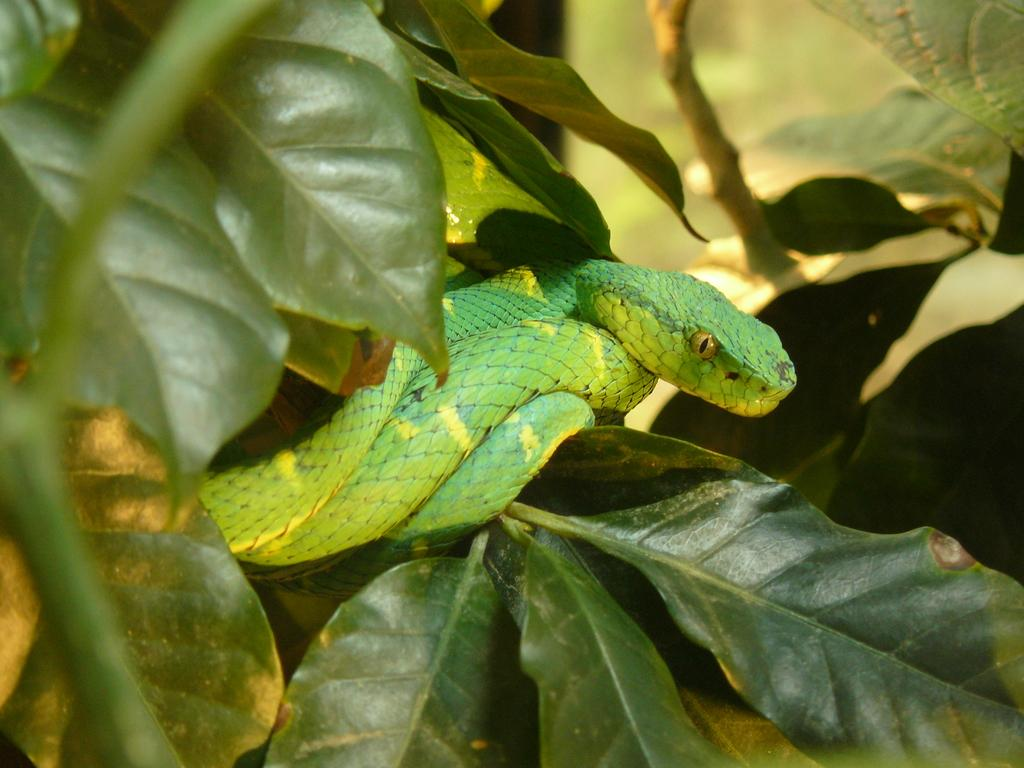What type of animal is in the image? There is a green color snake in the image. Where is the snake located? The snake is on a plant. What can be seen in the background of the image? There are leaves visible in the image. What type of chin can be seen on the snake in the image? Snakes do not have chins, so there is no chin visible on the snake in the image. 